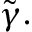Convert formula to latex. <formula><loc_0><loc_0><loc_500><loc_500>\tilde { \gamma } .</formula> 